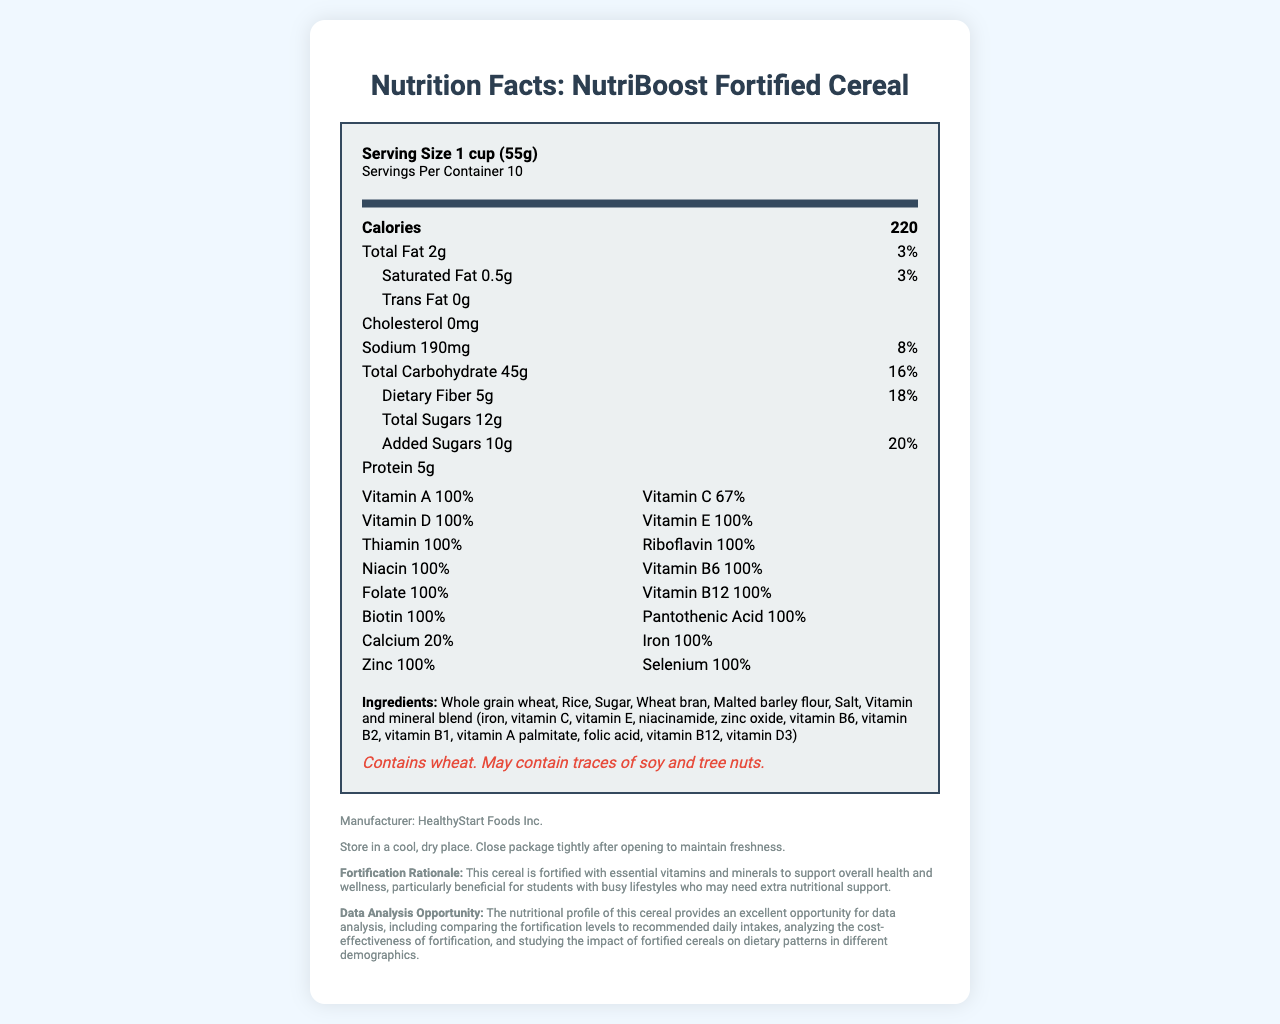what is the serving size? The serving size is listed at the top of the nutrition label, which specifies "Serving Size 1 cup (55g)".
Answer: 1 cup (55g) what are the main ingredients of NutriBoost Fortified Cereal? The ingredients are mentioned towards the end of the nutrition label under the "Ingredients" section.
Answer: Whole grain wheat, Rice, Sugar, Wheat bran, Malted barley flour, Salt, Vitamin and mineral blend what is the vitamin D content per serving, and what percentage of the daily value does it represent? The nutrition label lists Vitamin D content as 20mcg and the daily value as 100%.
Answer: 20mcg, 100% how many calories come from fats? The nutrition label does not specify the number of calories coming from fats explicitly.
Answer: Cannot be determined which nutrient has the highest daily value percentage? The label indicates multiple nutrients each at 100% daily value, making them the highest.
Answer: Several nutrients (Vitamin A, Vitamin D, Vitamin E, Thiamin, Riboflavin, Niacin, Vitamin B6, Folate, Vitamin B12, Biotin, Pantothenic Acid, Iron, Zinc, Selenium) each have 100% daily value. what is the total carbohydrate content per serving? The total carbohydrate content per serving is shown as 45g on the nutrition label.
Answer: 45g how much protein is in each serving? The protein content per serving is indicated as 5g.
Answer: 5g what company manufactures NutriBoost Fortified Cereal? The manufacturer is mentioned at the bottom of the document under "Manufacturer: HealthyStart Foods Inc."
Answer: HealthyStart Foods Inc. what is the storage recommendation for keeping NutriBoost Fortified Cereal fresh? The storage instructions are provided in the footer of the nutrition label.
Answer: Store in a cool, dry place. Close package tightly after opening to maintain freshness. how much sodium is there per serving, and what percentage of the daily value does it represent? The sodium content is listed as 190mg with a daily value of 8%.
Answer: 190mg, 8% how much dietary fiber is in one serving? The dietary fiber content is listed as 5g.
Answer: 5g which of the following vitamins is NOT present at 100% daily value? A. Vitamin A B. Vitamin C C. Vitamin D D. Zinc Vitamin C is present at 67% daily value, whereas the others are present at 100%.
Answer: B which mineral has the same daily value percentage as Vitamin B6? A. Calcium B. Iron C. Biotin D. Selenium Both Vitamin B6 and Selenium are listed at 100% daily value.
Answer: D does NutriBoost Fortified Cereal contain any allergens? The allergen information section notes that the cereal contains wheat and may contain traces of soy and tree nuts.
Answer: Yes please summarize the main purpose and notable features of this document. This summary covers the general structure and primary focus areas of the nutrition facts label.
Answer: The document is a nutrition facts label for NutriBoost Fortified Cereal. It provides detailed nutritional information per serving, including calorie content, macronutrient breakdown, and added vitamins and minerals. The label highlights that the cereal is fortified with essential nutrients, making it valuable for supporting overall health. It also contains ingredient, allergen, and storage information, along with a note on the manufacturer and fortification rationale. who is the target audience for this fortified cereal according to the document? The fortification rationale mentions that the cereal is particularly beneficial for students with busy lifestyles who may need extra nutritional support.
Answer: Students with busy lifestyles what percent of daily value does calcium represent in NutriBoost Fortified Cereal? The daily value percentage for calcium is listed as 20%.
Answer: 20% 